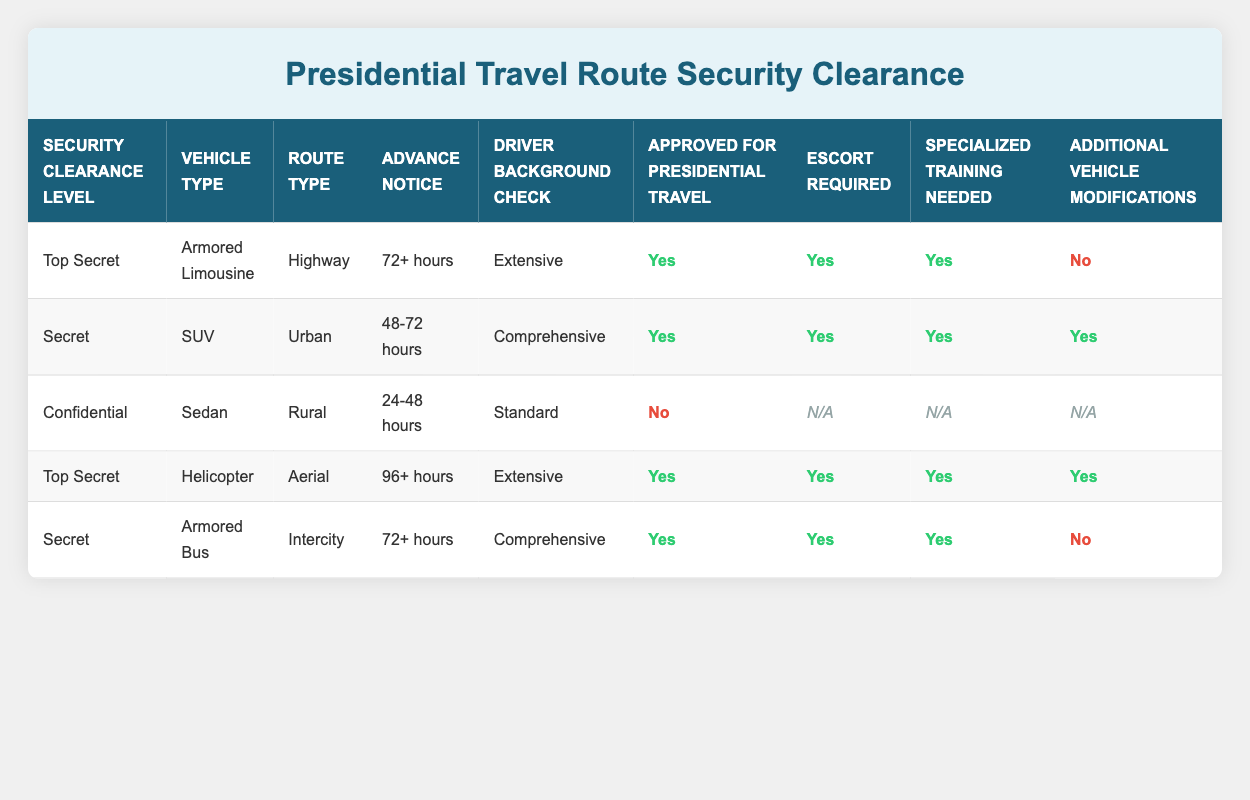What is the required advance notice for the Top Secret vehicle type Armored Limousine? The table states that for the vehicle type Armored Limousine with a Top Secret security clearance level, the advance notice required is 72+ hours.
Answer: 72+ hours How many rows in the table require an escort for presidential travel? There are three rows that have "Yes" under "Escort Required," which are for the Top Secret Armored Limousine, Top Secret Helicopter, and Secret Armored Bus. Total count is 3.
Answer: 3 Is the SUV approved for presidential travel? According to the table, the SUV with a Secret security clearance level is marked "Yes" for "Approved for Presidential Travel."
Answer: Yes Which vehicle type has a driver background check classified as "Standard"? The table indicates that the vehicle type Sedan has a driver background check classified as Standard and falls under the Confidential clearance level.
Answer: Sedan What is the maximum required advance notice among all vehicle types that are approved for presidential travel? The advance notices for approved vehicles are 72+ hours for both the Armored Limousine and Armored Bus, and 96+ hours for the Helicopter. The maximum advance notice is therefore 96+ hours for the Helicopter.
Answer: 96+ hours How many vehicle types do not require additional modifications for presidential travel? The table indicates that the Armored Limousine and Armored Bus do not require additional vehicle modifications, resulting in a total of 2 vehicle types.
Answer: 2 For which route type is the Sedan approved for presidential travel? The table shows that the Sedan with a Confidential security clearance level is marked "No" under "Approved for Presidential Travel," which means it is not approved for any route type.
Answer: No route type If a vehicle is marked as requiring specialized training, what is the range of security clearance levels that apply? The table reveals that specialized training is needed for vehicles with Top Secret and Secret clearance levels, specifically Armored Limousine, SUV, Armored Bus, and Helicopter. Therefore, the range is from Top Secret to Secret.
Answer: Top Secret to Secret Which vehicle requires the least advance notice for presidential travel without being approved? The Sedan requires an advance notice of 24-48 hours and is not approved for presidential travel, which is the least notice among the entries.
Answer: Sedan 